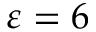Convert formula to latex. <formula><loc_0><loc_0><loc_500><loc_500>\varepsilon = 6</formula> 